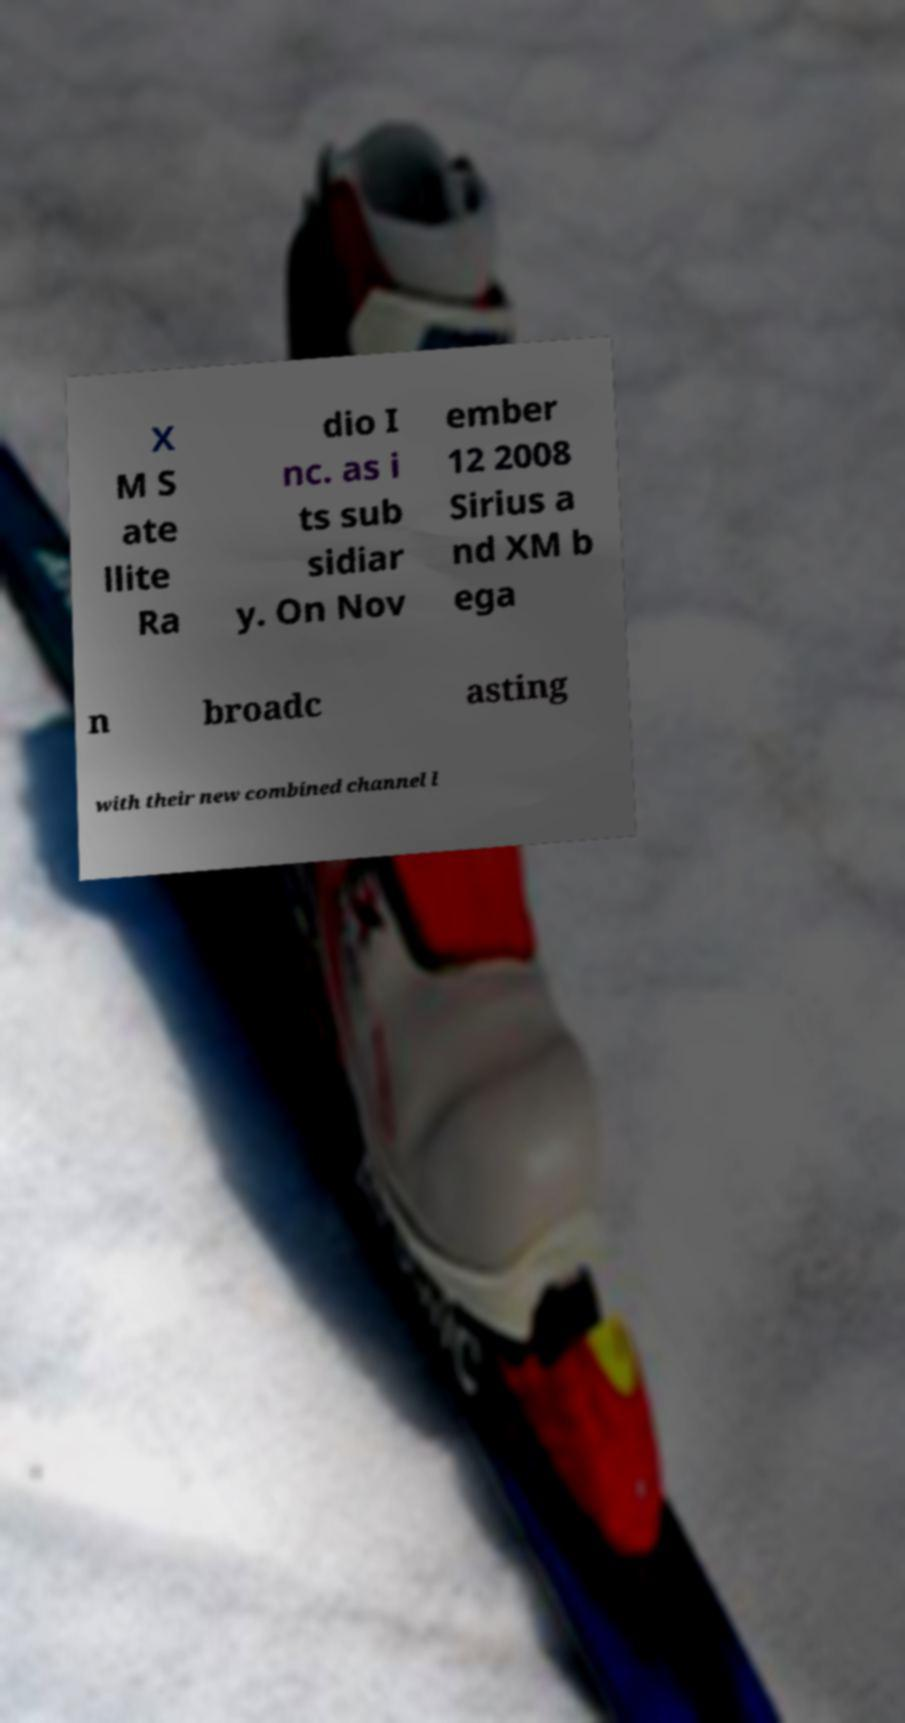Can you read and provide the text displayed in the image?This photo seems to have some interesting text. Can you extract and type it out for me? X M S ate llite Ra dio I nc. as i ts sub sidiar y. On Nov ember 12 2008 Sirius a nd XM b ega n broadc asting with their new combined channel l 